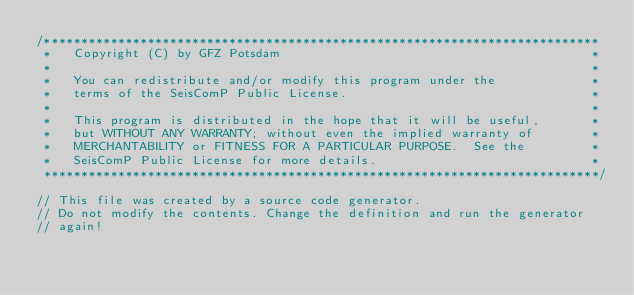<code> <loc_0><loc_0><loc_500><loc_500><_C++_>/***************************************************************************
 *   Copyright (C) by GFZ Potsdam                                          *
 *                                                                         *
 *   You can redistribute and/or modify this program under the             *
 *   terms of the SeisComP Public License.                                 *
 *                                                                         *
 *   This program is distributed in the hope that it will be useful,       *
 *   but WITHOUT ANY WARRANTY; without even the implied warranty of        *
 *   MERCHANTABILITY or FITNESS FOR A PARTICULAR PURPOSE.  See the         *
 *   SeisComP Public License for more details.                             *
 ***************************************************************************/

// This file was created by a source code generator.
// Do not modify the contents. Change the definition and run the generator
// again!

</code> 